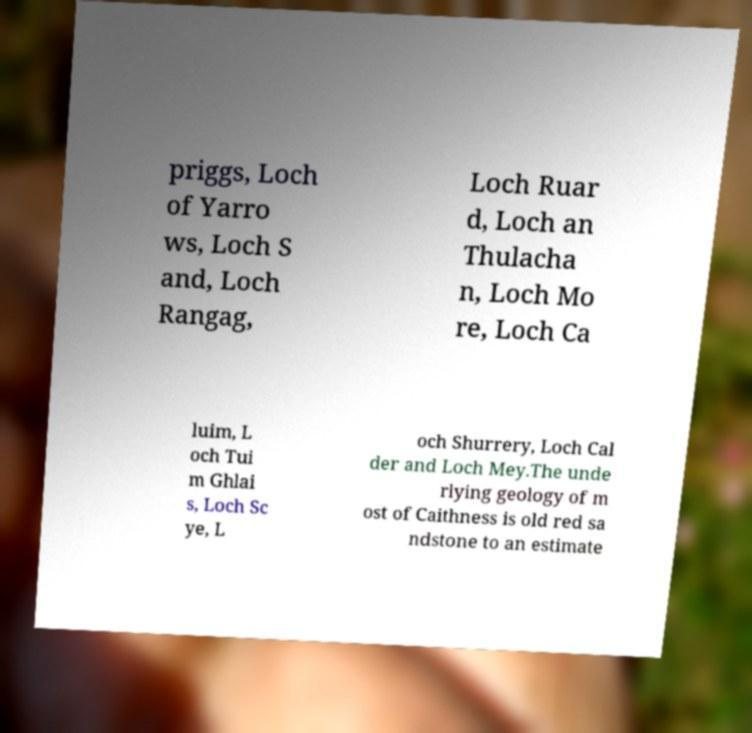Can you accurately transcribe the text from the provided image for me? priggs, Loch of Yarro ws, Loch S and, Loch Rangag, Loch Ruar d, Loch an Thulacha n, Loch Mo re, Loch Ca luim, L och Tui m Ghlai s, Loch Sc ye, L och Shurrery, Loch Cal der and Loch Mey.The unde rlying geology of m ost of Caithness is old red sa ndstone to an estimate 